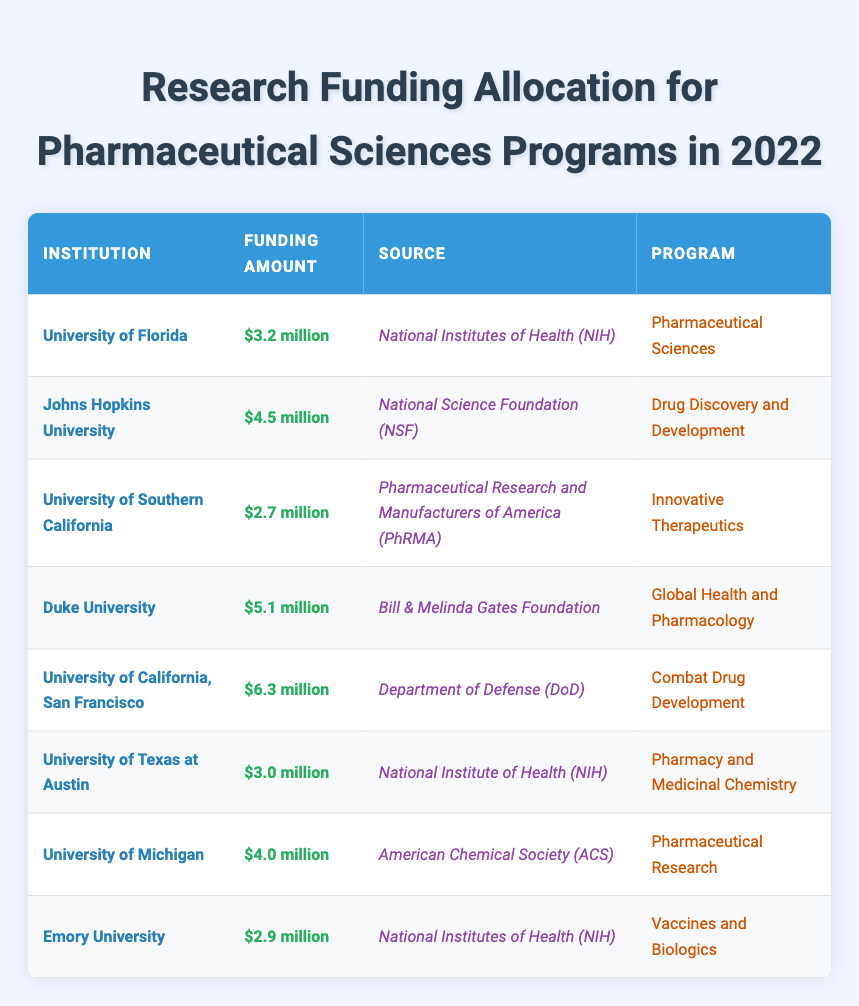What institution received the highest funding amount? The table lists various institutions along with their respective funding amounts. By examining the Funding Amount column, I see that the University of California, San Francisco received the highest amount of $6.3 million.
Answer: University of California, San Francisco What is the total funding amount allocated for all institutions listed? To calculate the total funding, I sum the individual funding amounts: $3.2 million + $4.5 million + $2.7 million + $5.1 million + $6.3 million + $3.0 million + $4.0 million + $2.9 million = $32.7 million.
Answer: $32.7 million Which source provided funding for the University of Texas at Austin? According to the table, the University of Texas at Austin received funding from the National Institute of Health (NIH), as shown in the Source column corresponding to that institution.
Answer: National Institute of Health (NIH) Did any institution receive more than $5 million in funding? By looking at the Funding Amounts, I find that the University of California, San Francisco ($6.3 million) and Duke University ($5.1 million) both received more than $5 million. Therefore, the answer is yes.
Answer: Yes What is the average funding amount across all programs? First, sum the total funding amounts: $3.2 + $4.5 + $2.7 + $5.1 + $6.3 + $3.0 + $4.0 + $2.9, which equals $32.7 million. There are 8 institutions, so to find the average, I divide the total by 8: $32.7 million / 8 = $4.0875 million.
Answer: $4.09 million What program received the least amount of funding? I examine the Program column alongside the Funding Amounts. The University of Southern California's program, Innovative Therapeutics, received the least funding of $2.7 million.
Answer: Innovative Therapeutics Is the total funding for programs associated with the National Institutes of Health (NIH) greater than $10 million? Two programs funded by NIH are listed: University of Florida ($3.2 million) and Emory University ($2.9 million). Adding these amounts gives: $3.2 million + $2.9 million = $6.1 million. Since $6.1 million is less than $10 million, the answer is no.
Answer: No How many programs received funding from the National Science Foundation (NSF)? The table shows that only one program, Drug Discovery and Development, received funding from the National Science Foundation (NSF) at Johns Hopkins University.
Answer: 1 What is the difference in funding between the highest and lowest funded institution? The highest funded institution is the University of California, San Francisco ($6.3 million) and the lowest is the University of Southern California ($2.7 million). The difference in funding amounts is $6.3 million - $2.7 million = $3.6 million.
Answer: $3.6 million 